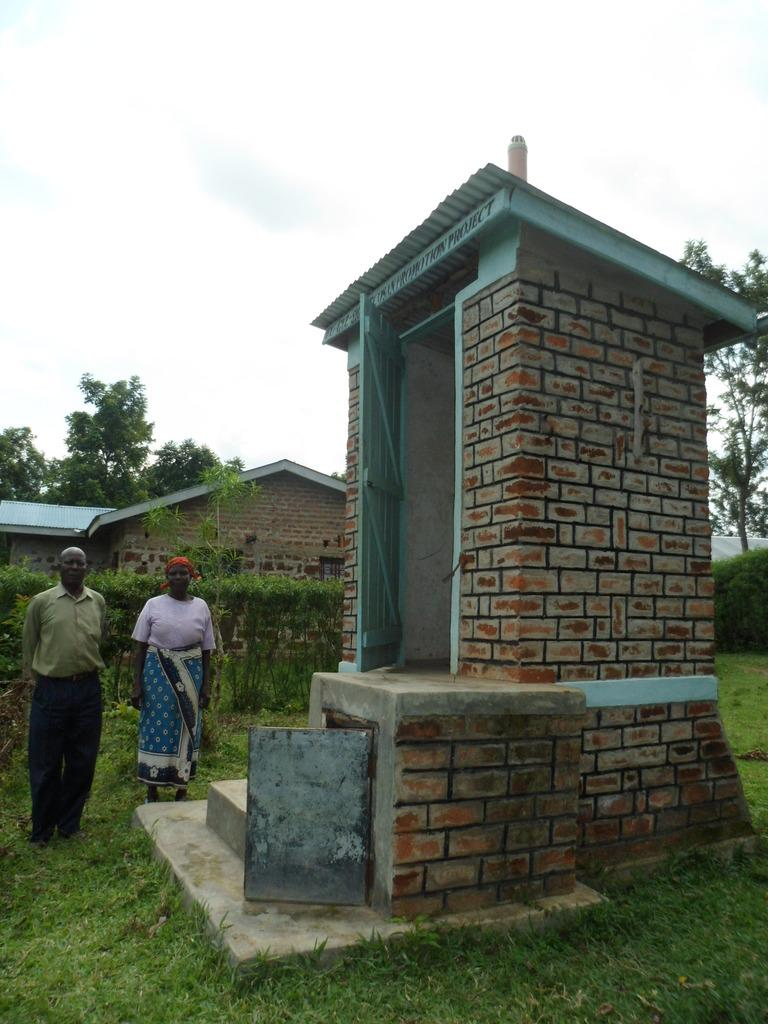What structure is the main subject of the image? There is a building in the image. What are the two persons in the image doing? The two persons are standing on the grass in the image. What can be seen in the background of the image? There are trees, buildings, and the sky visible in the background of the image. What type of instrument is the beast playing in the image? There is no beast or instrument present in the image. 